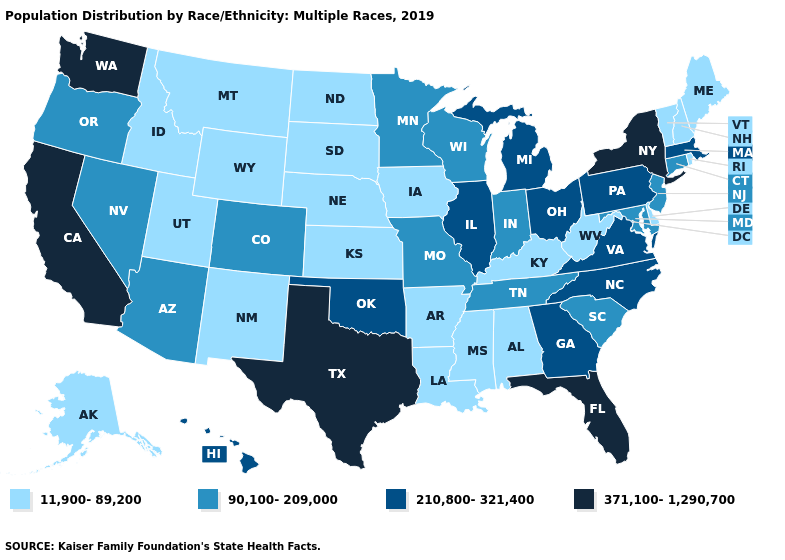What is the value of Indiana?
Write a very short answer. 90,100-209,000. How many symbols are there in the legend?
Answer briefly. 4. Name the states that have a value in the range 11,900-89,200?
Write a very short answer. Alabama, Alaska, Arkansas, Delaware, Idaho, Iowa, Kansas, Kentucky, Louisiana, Maine, Mississippi, Montana, Nebraska, New Hampshire, New Mexico, North Dakota, Rhode Island, South Dakota, Utah, Vermont, West Virginia, Wyoming. What is the highest value in the MidWest ?
Give a very brief answer. 210,800-321,400. Name the states that have a value in the range 11,900-89,200?
Be succinct. Alabama, Alaska, Arkansas, Delaware, Idaho, Iowa, Kansas, Kentucky, Louisiana, Maine, Mississippi, Montana, Nebraska, New Hampshire, New Mexico, North Dakota, Rhode Island, South Dakota, Utah, Vermont, West Virginia, Wyoming. What is the lowest value in the Northeast?
Answer briefly. 11,900-89,200. Is the legend a continuous bar?
Short answer required. No. What is the lowest value in the Northeast?
Write a very short answer. 11,900-89,200. Does Florida have a higher value than Washington?
Write a very short answer. No. Name the states that have a value in the range 210,800-321,400?
Quick response, please. Georgia, Hawaii, Illinois, Massachusetts, Michigan, North Carolina, Ohio, Oklahoma, Pennsylvania, Virginia. What is the value of Wyoming?
Concise answer only. 11,900-89,200. What is the highest value in the South ?
Keep it brief. 371,100-1,290,700. Among the states that border South Carolina , which have the lowest value?
Short answer required. Georgia, North Carolina. Name the states that have a value in the range 90,100-209,000?
Keep it brief. Arizona, Colorado, Connecticut, Indiana, Maryland, Minnesota, Missouri, Nevada, New Jersey, Oregon, South Carolina, Tennessee, Wisconsin. What is the lowest value in states that border Washington?
Concise answer only. 11,900-89,200. 